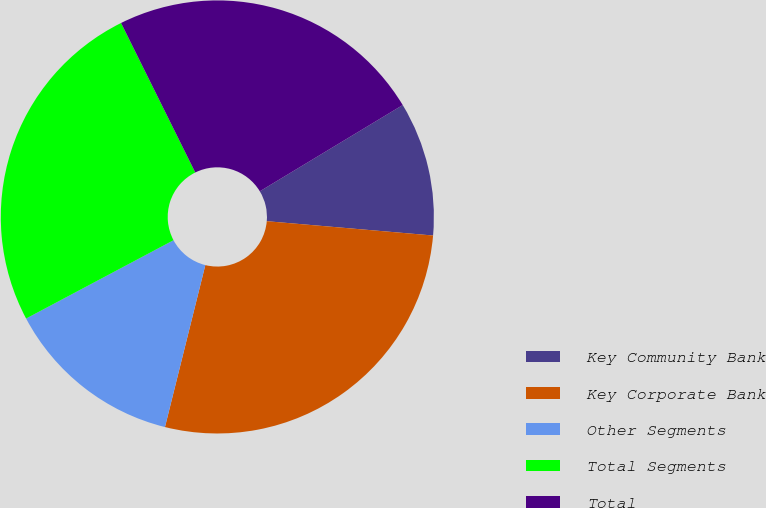Convert chart to OTSL. <chart><loc_0><loc_0><loc_500><loc_500><pie_chart><fcel>Key Community Bank<fcel>Key Corporate Bank<fcel>Other Segments<fcel>Total Segments<fcel>Total<nl><fcel>10.01%<fcel>27.52%<fcel>13.34%<fcel>25.44%<fcel>23.69%<nl></chart> 